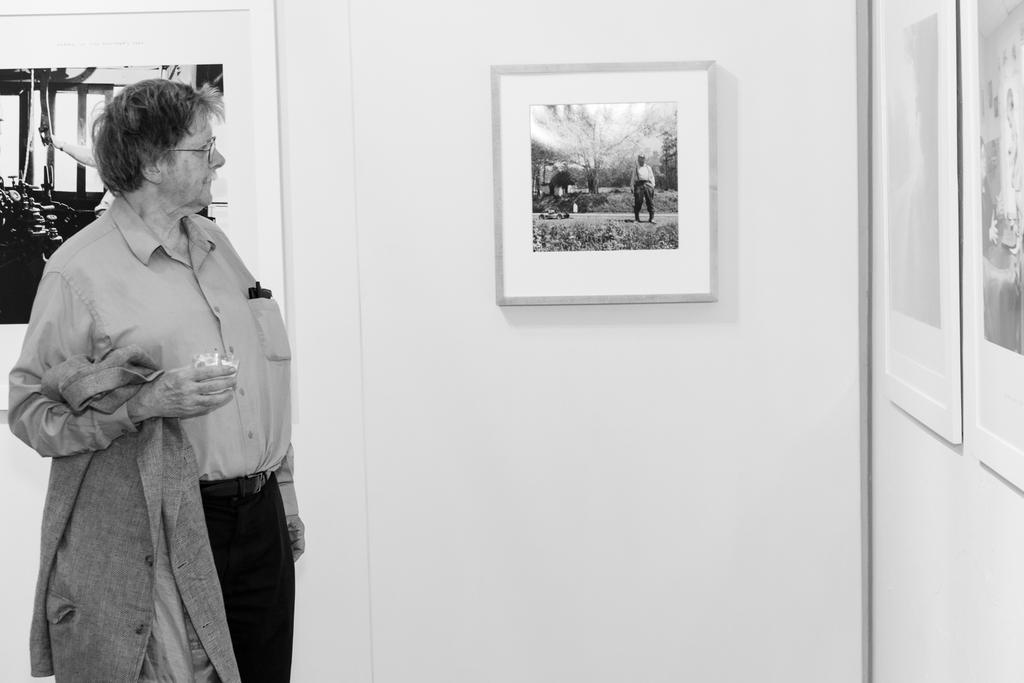What is the man in the image doing? The man is standing in the image. What is the man holding in his hands? The man is holding a jacket and a cup. What can be seen on the wall in the image? There are photo frames on the wall. What is the color scheme of the image? The image is in black and white color. What type of end is visible in the image? There is no end visible in the image; it is a photograph of a man standing with a jacket and a cup. How many bits of apparel can be seen on the man in the image? The man is only holding a jacket, so there is one piece of apparel visible in the image. 